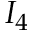Convert formula to latex. <formula><loc_0><loc_0><loc_500><loc_500>I _ { 4 }</formula> 